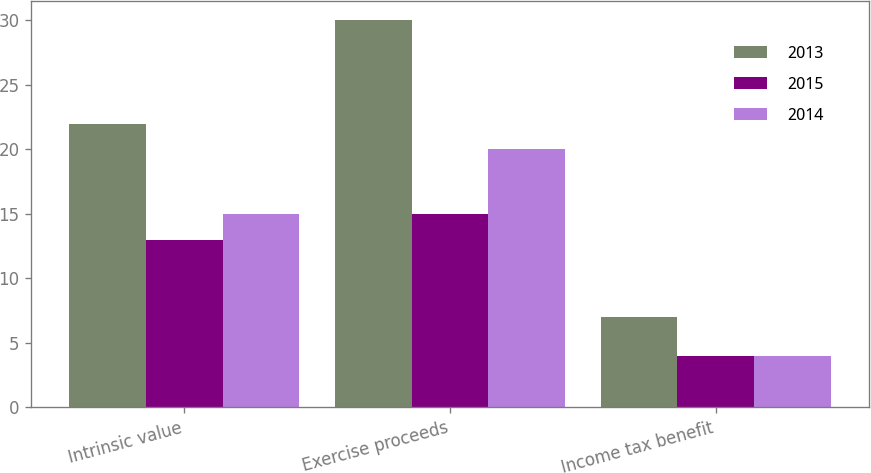Convert chart to OTSL. <chart><loc_0><loc_0><loc_500><loc_500><stacked_bar_chart><ecel><fcel>Intrinsic value<fcel>Exercise proceeds<fcel>Income tax benefit<nl><fcel>2013<fcel>22<fcel>30<fcel>7<nl><fcel>2015<fcel>13<fcel>15<fcel>4<nl><fcel>2014<fcel>15<fcel>20<fcel>4<nl></chart> 